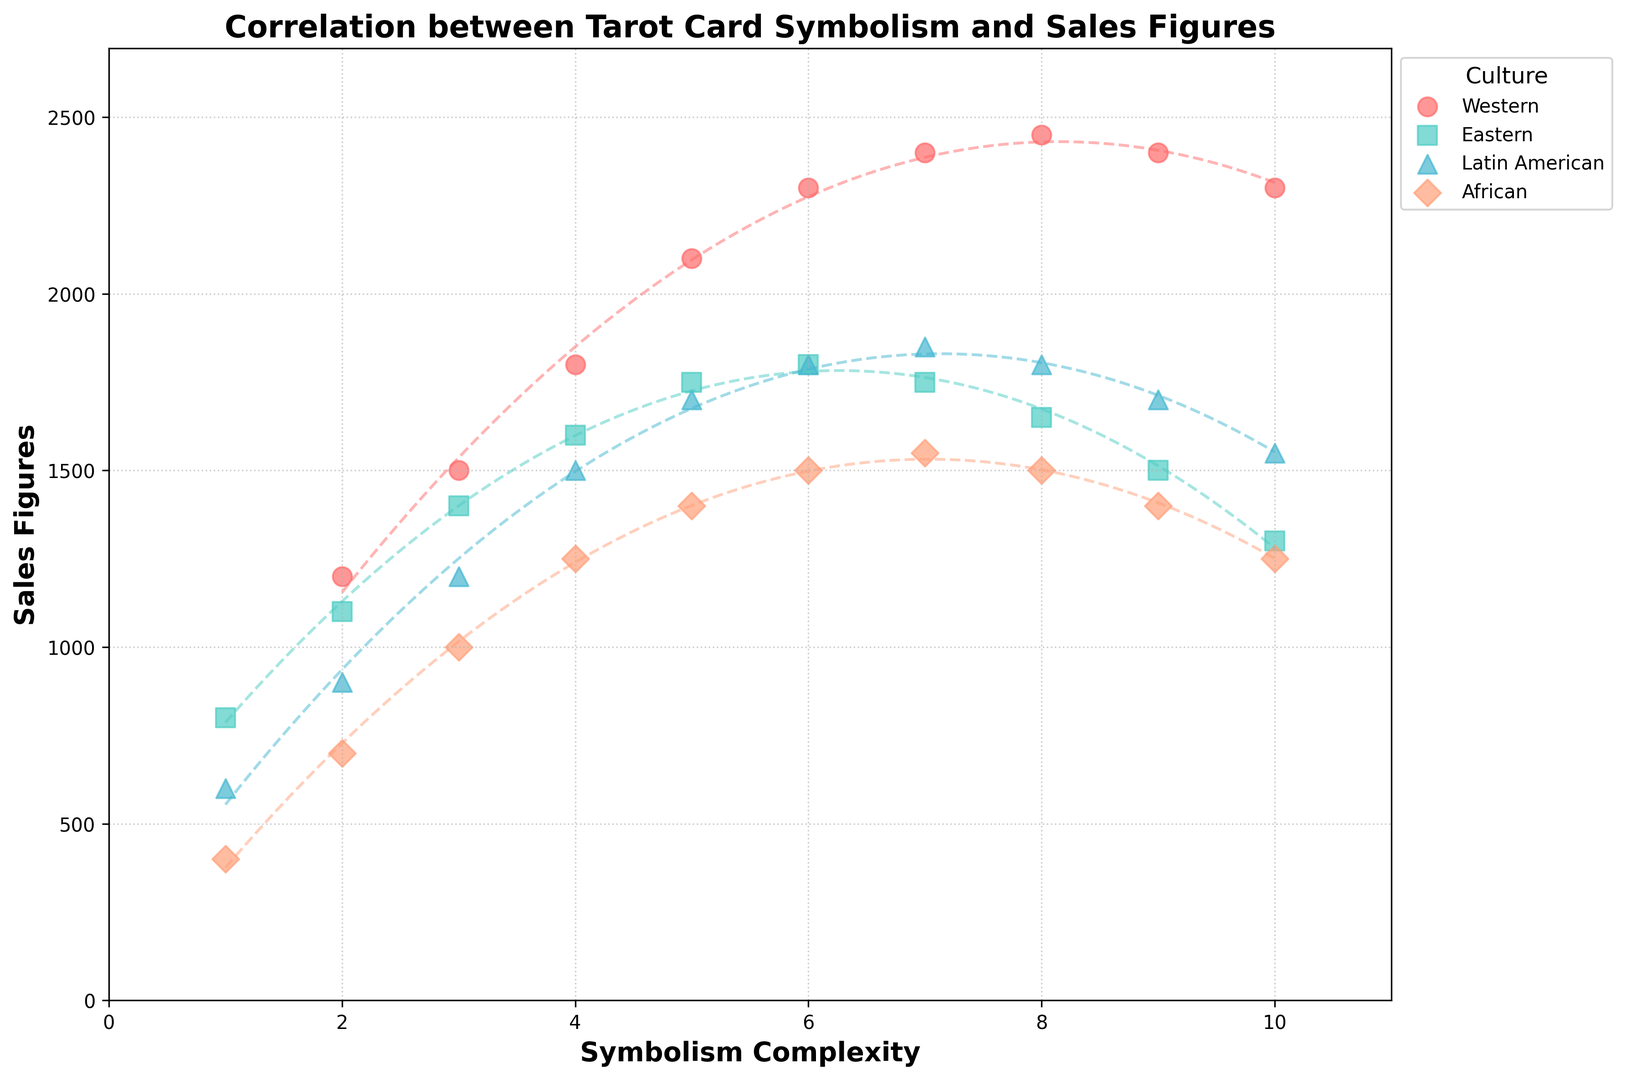Which culture shows the highest peak in sales figures? To find the culture with the highest peak in sales figures, observe the highest points in the scatter plot for all cultures. The Western culture has a point at 2450 sales, which is the highest peak.
Answer: Western At what symbolism complexity does the Western culture reach its highest sales figure? For the Western culture, the highest sales figure is 2450. Trace this point horizontally to the symbolism complexity axis, which corresponds to a complexity of 8.
Answer: 8 Compare the tendency of sales with increasing symbolism complexity in Eastern and Western cultures. Which culture shows a higher overall sensitivity in sales figures? Observe the trend lines (polynomial fits) for both Eastern (blue) and Western (red) cultures. The Western culture shows a sharper increase and then a decrease in sales figures as symbolism complexity increases compared to the more consistent but lower range in Eastern culture.
Answer: Western culture Within which range of symbolism complexities do all cultures show declining sales figures? Analyze the trend lines of each culture. Notice that after a complexity of around 8-9, all cultures begin to show declining sales trends.
Answer: 8-10 Compute the average sales figure for Eastern culture at symbolism complexities 4, 5, and 6. For Eastern culture, extract sales figures: 1600 at complexity 4, 1750 at complexity 5, and 1800 at complexity 6. The average is (1600 + 1750 + 1800) / 3 = 1716.67.
Answer: 1716.67 In terms of visual density, which culture has the most data points clustered at higher symbolism complexities (7-10)? Count the number of data points in the range 7-10 for all cultures. The Western culture shows a higher number of clustered data points in this range compared to other cultures.
Answer: Western Which culture shows the flattest trend line across different symbolism complexities? Examine the trend lines of all cultures. The trend line for the African culture (green) appears to be the flattest, indicating minimal variation in sales figures across different complexities.
Answer: African Compare the sales figures at the lowest symbolism complexity (1) across all cultures. Which culture has the highest sales figure at this complexity? For symbolism complexity 1, the sales figures are Western: 1200, Eastern: 800, Latin American: 600, and African: 400. Thus, the Western culture has the highest sales figure at this complexity.
Answer: Western Which culture's trend line depicts a peak followed by a decline at a lower symbolism complexity compared to others? Look at each culture's trend line. The Latin American culture (orange) peaks and then declines around a complexity of 7, which is lower than where Western peaks (8).
Answer: Latin American Identify the symbolism complexity where African and Eastern cultures have equal sales figures and specify the value. Observe where the blue (Eastern) and green (African) trend lines intersect. This is around a complexity of 8, with an approximate sales figure of 1500.
Answer: 8, 1500 